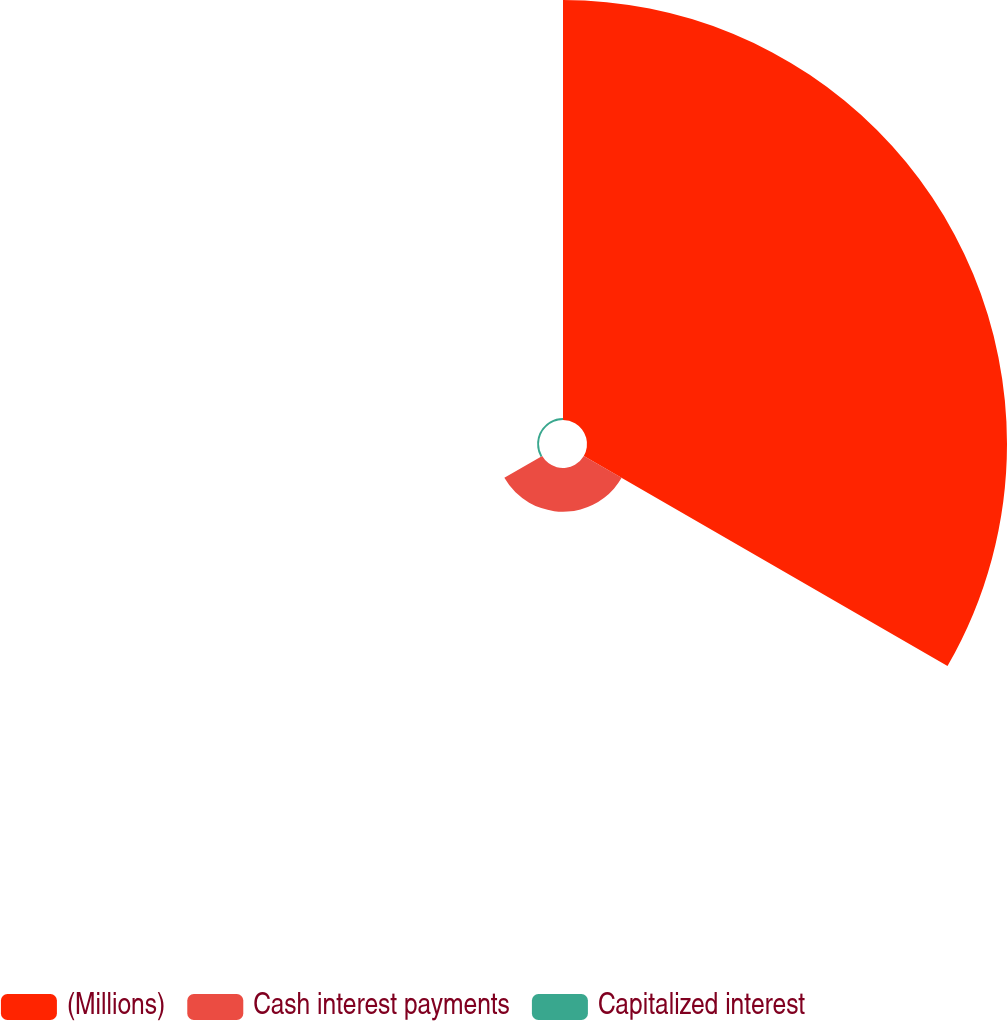<chart> <loc_0><loc_0><loc_500><loc_500><pie_chart><fcel>(Millions)<fcel>Cash interest payments<fcel>Capitalized interest<nl><fcel>90.21%<fcel>9.39%<fcel>0.41%<nl></chart> 